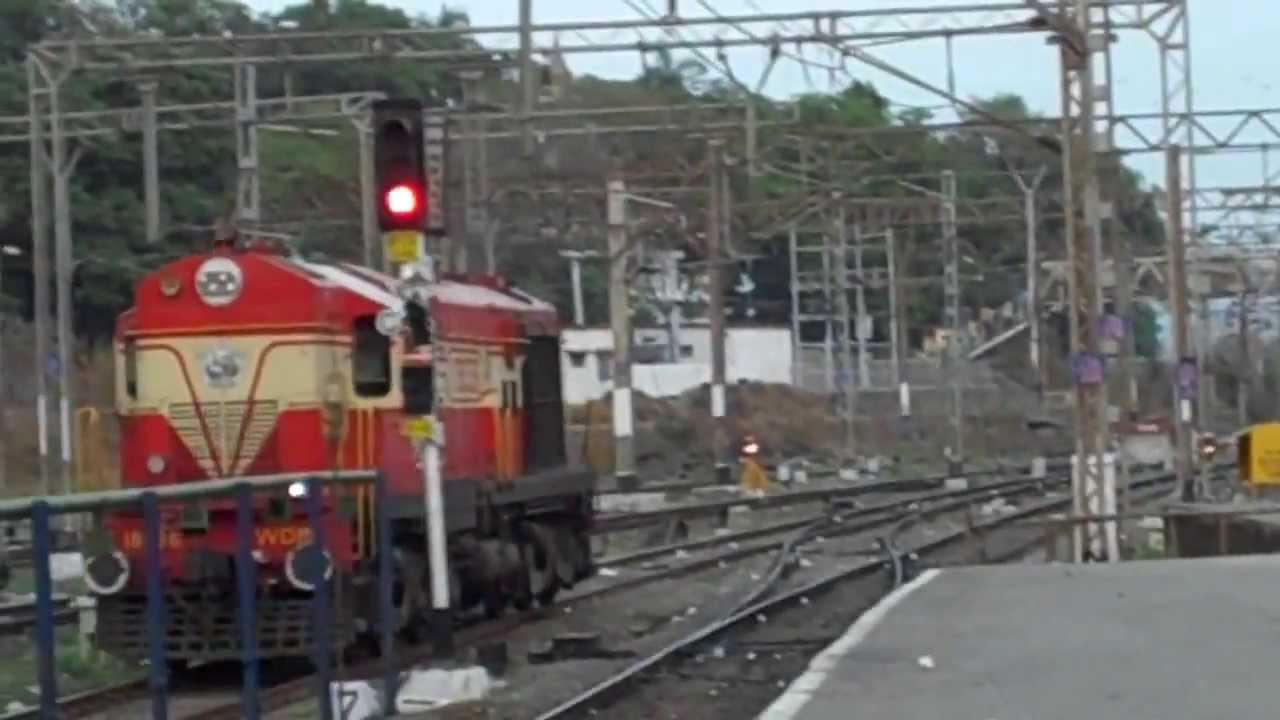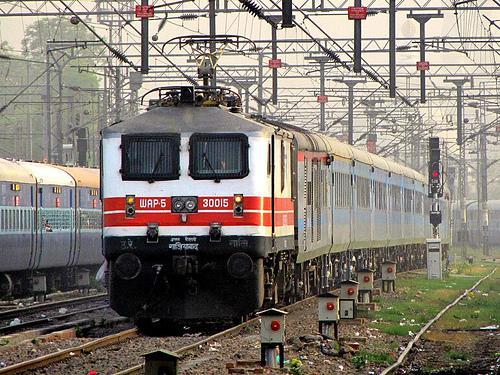The first image is the image on the left, the second image is the image on the right. For the images shown, is this caption "There are two trains in the image on the right." true? Answer yes or no. Yes. 